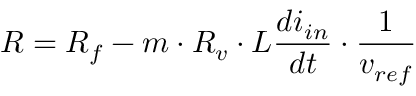Convert formula to latex. <formula><loc_0><loc_0><loc_500><loc_500>R = R _ { f } - m \cdot R _ { v } \cdot L \frac { d i _ { i n } } { d t } \cdot \frac { 1 } { v _ { r e f } }</formula> 